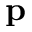<formula> <loc_0><loc_0><loc_500><loc_500>p</formula> 